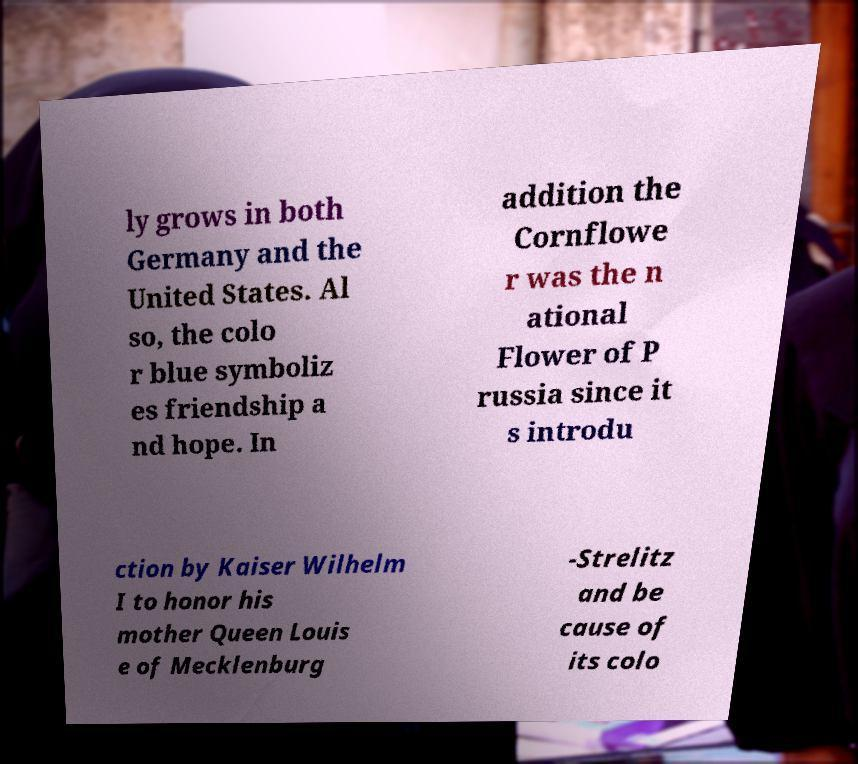Please identify and transcribe the text found in this image. ly grows in both Germany and the United States. Al so, the colo r blue symboliz es friendship a nd hope. In addition the Cornflowe r was the n ational Flower of P russia since it s introdu ction by Kaiser Wilhelm I to honor his mother Queen Louis e of Mecklenburg -Strelitz and be cause of its colo 